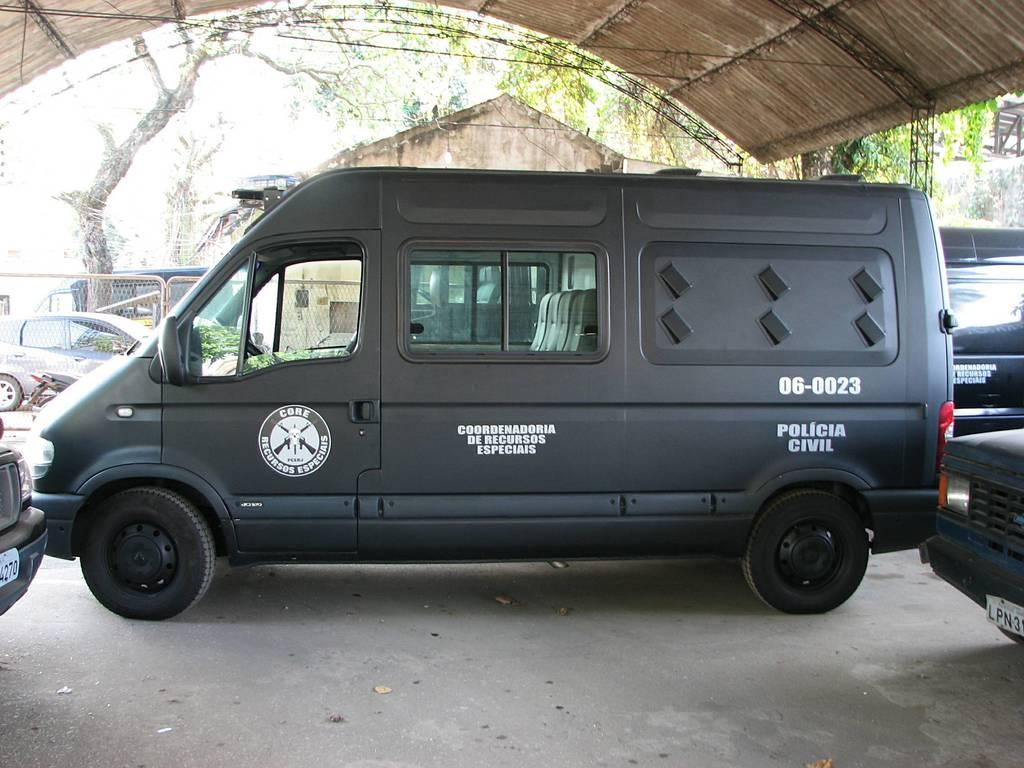<image>
Describe the image concisely. A black van used by the Policia Civil has the back windows covered up. 